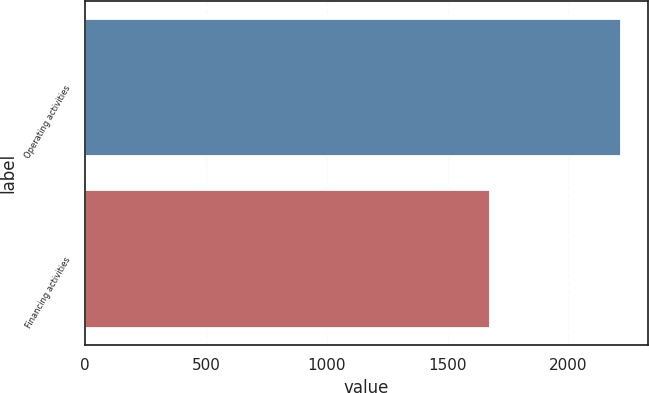Convert chart. <chart><loc_0><loc_0><loc_500><loc_500><bar_chart><fcel>Operating activities<fcel>Financing activities<nl><fcel>2217<fcel>1677<nl></chart> 